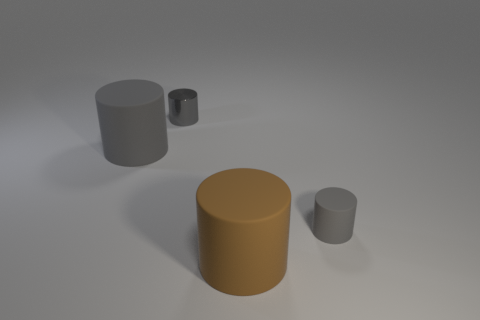Subtract all gray cylinders. How many were subtracted if there are1gray cylinders left? 2 Subtract all gray balls. How many gray cylinders are left? 3 Subtract 1 cylinders. How many cylinders are left? 3 Add 3 big blue matte blocks. How many objects exist? 7 Add 2 brown rubber cylinders. How many brown rubber cylinders are left? 3 Add 2 big brown matte cylinders. How many big brown matte cylinders exist? 3 Subtract 0 cyan cylinders. How many objects are left? 4 Subtract all tiny gray cylinders. Subtract all cyan cylinders. How many objects are left? 2 